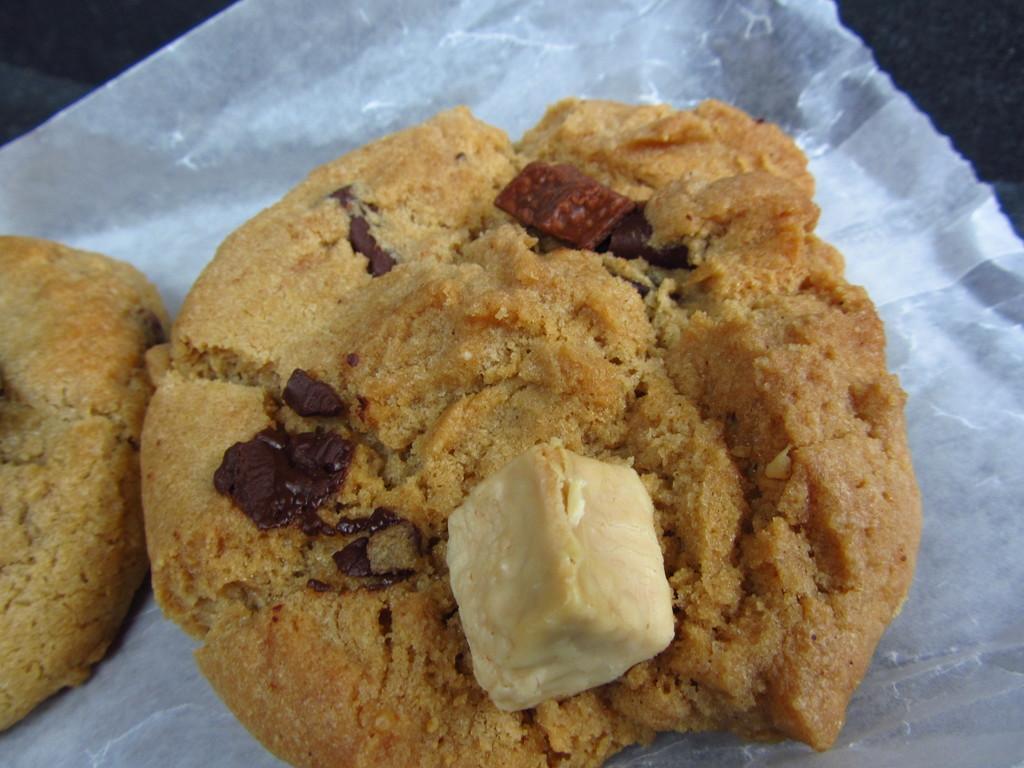How would you summarize this image in a sentence or two? In this image I can see the food which is in brown and cream color. The food is on the white color paper. And there is a black background. 